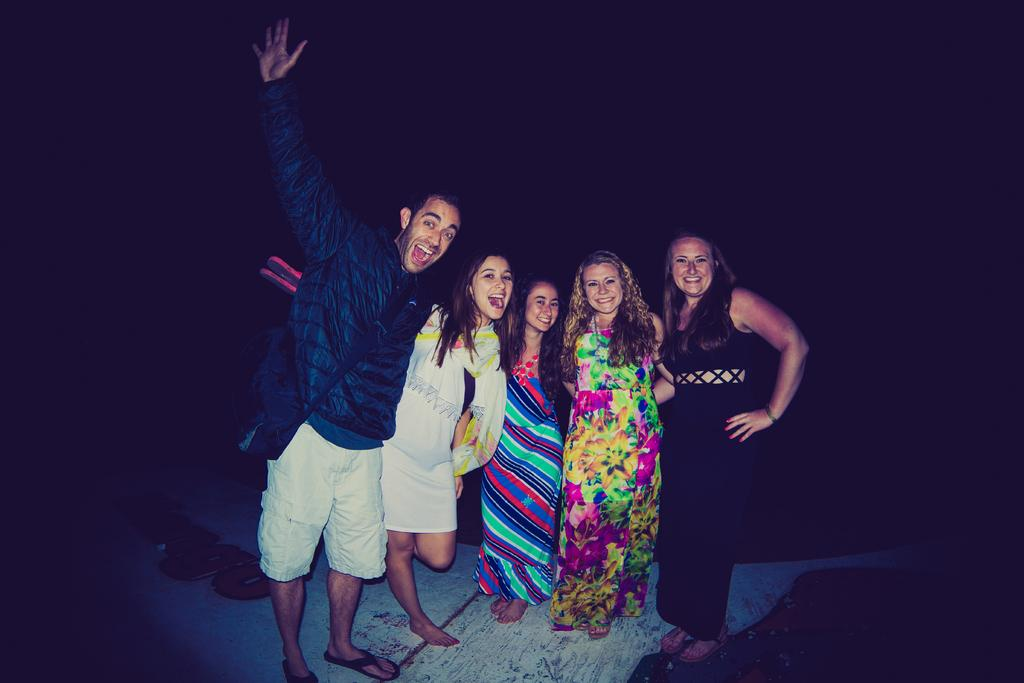How many people are in the image? There are 4 women and a man in the image, making a total of 5 people. What are the people in the image doing? All of them are standing and smiling. What can be seen in the foreground of the image? There is a path visible in the image. What is the color of the background in the image? The background of the image is dark. What type of square can be seen in the image? There is no square present in the image. Is there a chess game being played in the image? There is no chess game or any indication of a game being played in the image. 